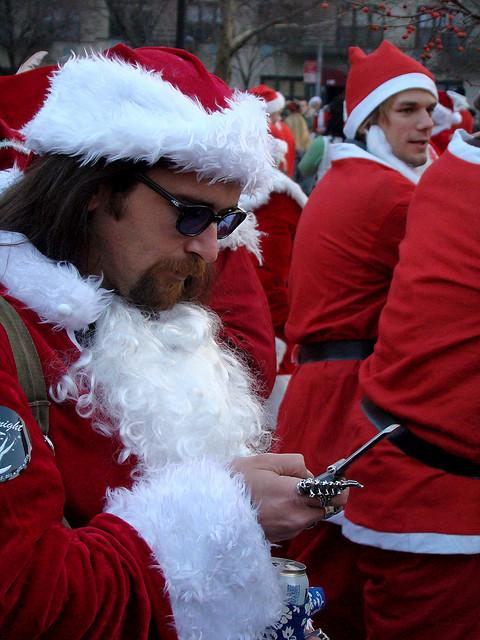What Christmas character are these people all dressed up as? santa 